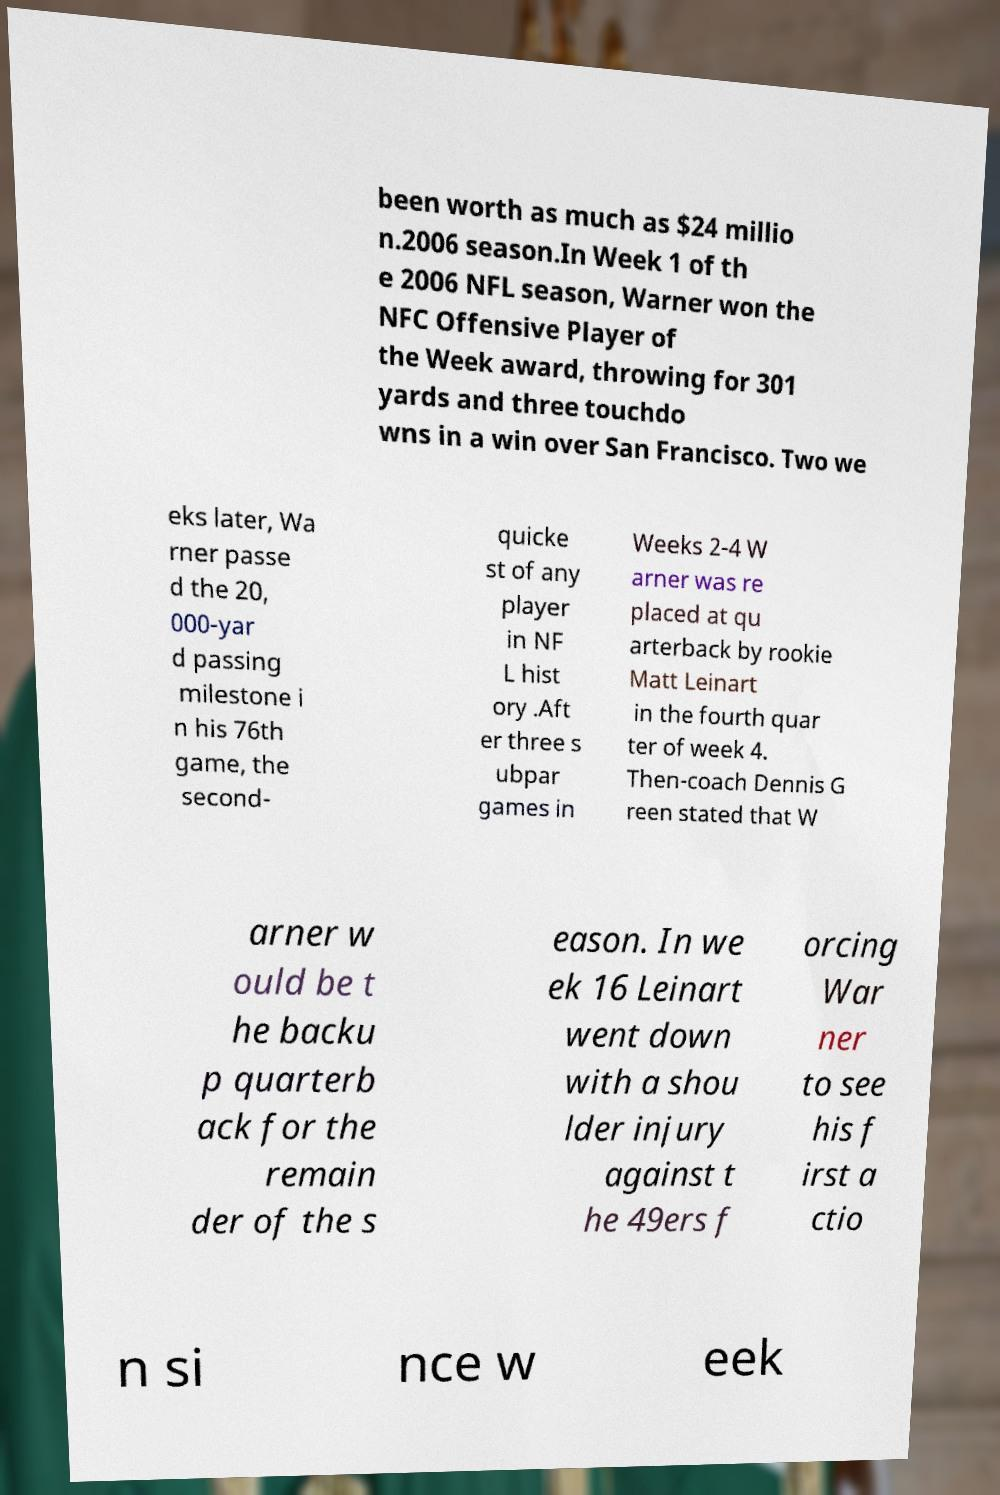Please identify and transcribe the text found in this image. been worth as much as $24 millio n.2006 season.In Week 1 of th e 2006 NFL season, Warner won the NFC Offensive Player of the Week award, throwing for 301 yards and three touchdo wns in a win over San Francisco. Two we eks later, Wa rner passe d the 20, 000-yar d passing milestone i n his 76th game, the second- quicke st of any player in NF L hist ory .Aft er three s ubpar games in Weeks 2-4 W arner was re placed at qu arterback by rookie Matt Leinart in the fourth quar ter of week 4. Then-coach Dennis G reen stated that W arner w ould be t he backu p quarterb ack for the remain der of the s eason. In we ek 16 Leinart went down with a shou lder injury against t he 49ers f orcing War ner to see his f irst a ctio n si nce w eek 